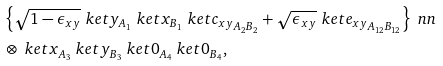Convert formula to latex. <formula><loc_0><loc_0><loc_500><loc_500>& \left \{ \sqrt { 1 - \epsilon _ { x y } } \ k e t { y } _ { A _ { 1 } } \ k e t { x } _ { B _ { 1 } } \ k e t { c _ { x y } } _ { A _ { 2 } B _ { 2 } } + \sqrt { \epsilon _ { x y } } \ k e t { e _ { x y } } _ { A _ { 1 2 } B _ { 1 2 } } \right \} \ n n \\ & \otimes \ k e t { x } _ { A _ { 3 } } \ k e t { y } _ { B _ { 3 } } \ k e t { 0 } _ { A _ { 4 } } \ k e t { 0 } _ { B _ { 4 } } ,</formula> 